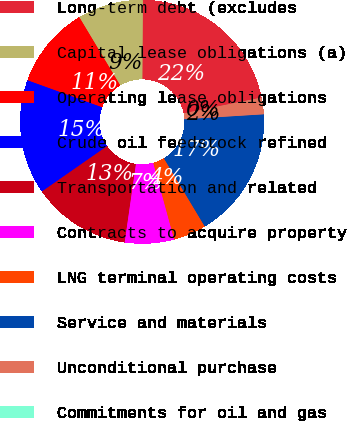Convert chart to OTSL. <chart><loc_0><loc_0><loc_500><loc_500><pie_chart><fcel>Long-term debt (excludes<fcel>Capital lease obligations (a)<fcel>Operating lease obligations<fcel>Crude oil feedstock refined<fcel>Transportation and related<fcel>Contracts to acquire property<fcel>LNG terminal operating costs<fcel>Service and materials<fcel>Unconditional purchase<fcel>Commitments for oil and gas<nl><fcel>21.73%<fcel>8.7%<fcel>10.87%<fcel>15.21%<fcel>13.04%<fcel>6.52%<fcel>4.35%<fcel>17.39%<fcel>2.18%<fcel>0.01%<nl></chart> 